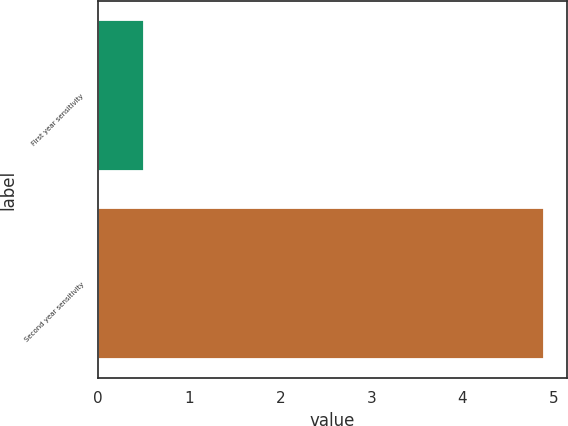<chart> <loc_0><loc_0><loc_500><loc_500><bar_chart><fcel>First year sensitivity<fcel>Second year sensitivity<nl><fcel>0.5<fcel>4.9<nl></chart> 